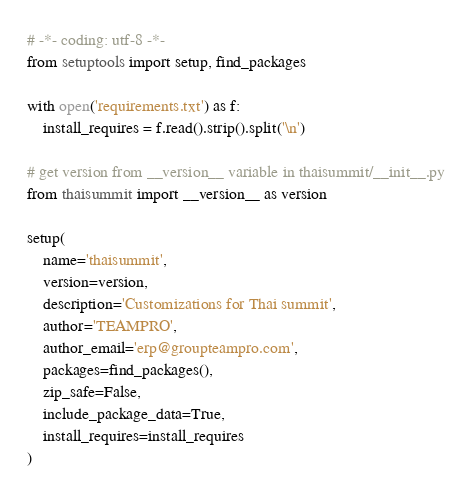<code> <loc_0><loc_0><loc_500><loc_500><_Python_># -*- coding: utf-8 -*-
from setuptools import setup, find_packages

with open('requirements.txt') as f:
	install_requires = f.read().strip().split('\n')

# get version from __version__ variable in thaisummit/__init__.py
from thaisummit import __version__ as version

setup(
	name='thaisummit',
	version=version,
	description='Customizations for Thai summit',
	author='TEAMPRO',
	author_email='erp@groupteampro.com',
	packages=find_packages(),
	zip_safe=False,
	include_package_data=True,
	install_requires=install_requires
)
</code> 